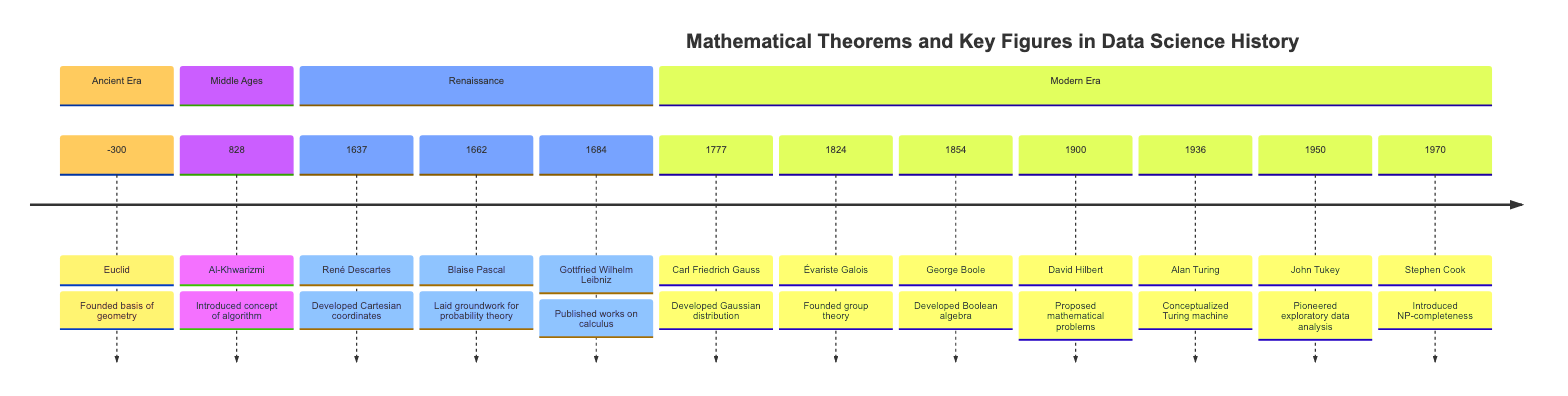What year did Euclid contribute to mathematics? The diagram shows that Euclid's contribution was made in 300 BC. This is directly stated in the Ancient Era section of the timeline.
Answer: 300 Who introduced the concept of algorithms? According to the timeline, Al-Khwarizmi introduced the concept of algorithms in the year 828. This is found in the Middle Ages section.
Answer: Al-Khwarizmi Which mathematician developed Cartesian coordinates? The diagram indicates that René Descartes developed Cartesian coordinates in 1637, as stated in the Renaissance section.
Answer: René Descartes What foundational mathematical concept did Blaise Pascal lay the groundwork for? The diagram indicates Blaise Pascal laid groundwork for probability theory in 1662. This information is provided in the list of contributions in the Renaissance era.
Answer: Probability theory Which mathematician's work was crucial in developing the Gaussian distribution? According to the timeline, Carl Friedrich Gauss developed the Gaussian distribution in 1777. This is specified in the Modern Era section of the diagram.
Answer: Carl Friedrich Gauss How many key figures are mentioned in the Modern Era? The timeline lists 7 key figures in the Modern Era, namely Carl Friedrich Gauss, Évariste Galois, George Boole, David Hilbert, Alan Turing, John Tukey, and Stephen Cook. This total is derived by counting each name listed in that section.
Answer: 7 What theorem is associated with George Boole? The diagram specifies that George Boole developed Boolean algebra, making Boolean algebra the theorem associated with him as found in the Modern Era section.
Answer: Boolean algebra Who proposed the mathematical problems in 1900? From the timeline, it is clear that David Hilbert proposed mathematical problems in 1900, as indicated in the Modern Era section.
Answer: David Hilbert What year did Alan Turing conceptualize the Turing machine? The diagram indicates that Alan Turing conceptualized the Turing machine in 1936, which is clearly displayed in the Modern Era section of the timeline.
Answer: 1936 